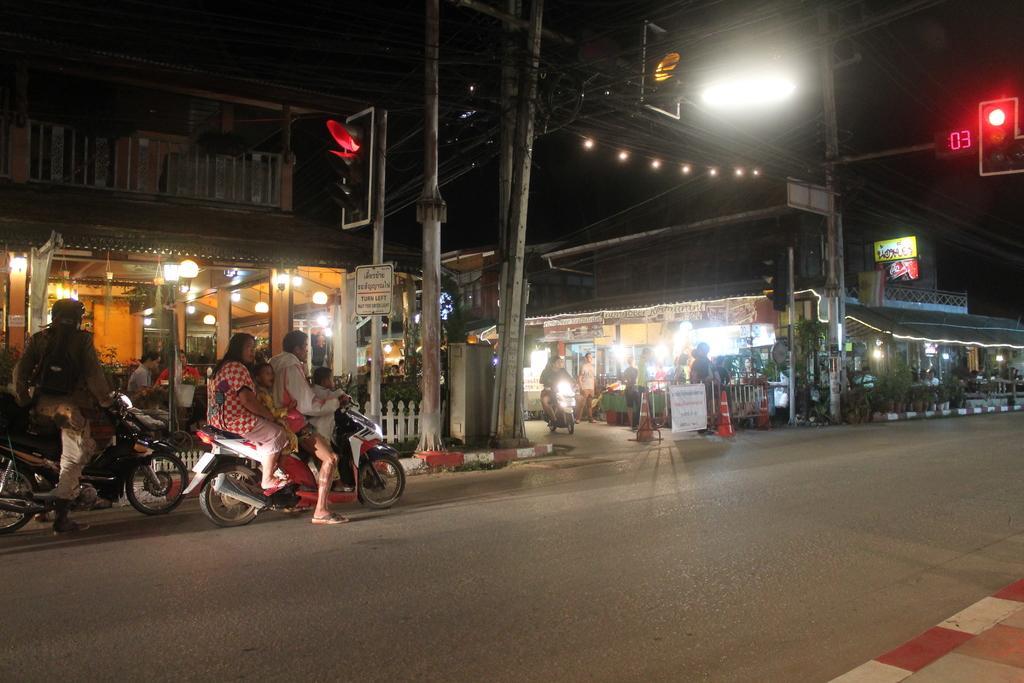In one or two sentences, can you explain what this image depicts? As we can see in the image there are buildings, lights, traffic signals, few people here and there and few of them are sitting on motor cycles. 